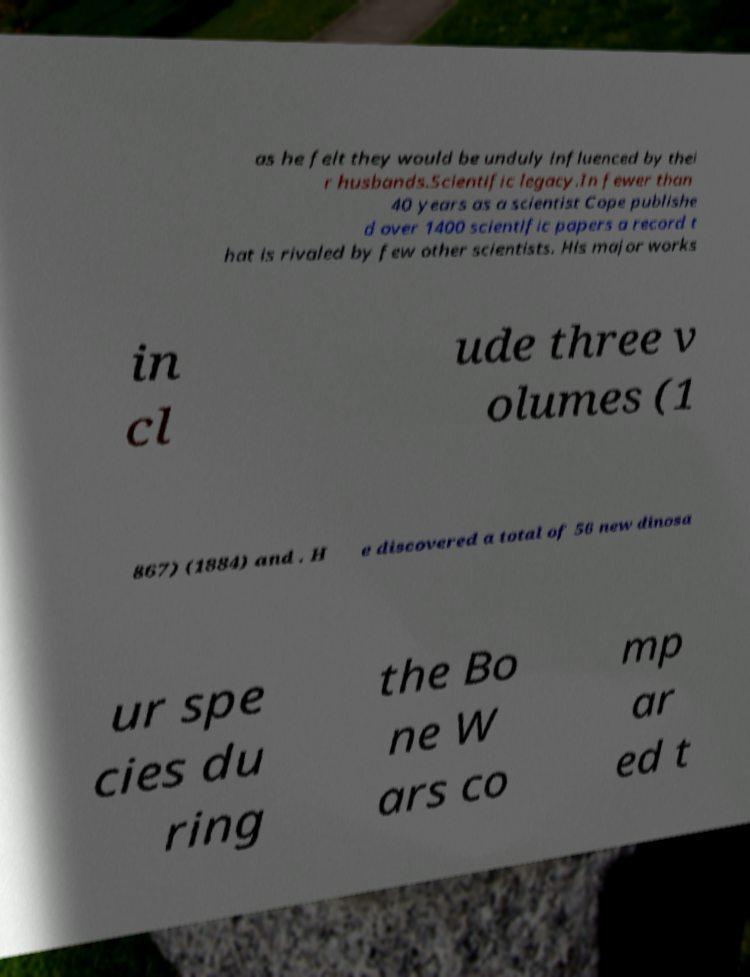Can you read and provide the text displayed in the image?This photo seems to have some interesting text. Can you extract and type it out for me? as he felt they would be unduly influenced by thei r husbands.Scientific legacy.In fewer than 40 years as a scientist Cope publishe d over 1400 scientific papers a record t hat is rivaled by few other scientists. His major works in cl ude three v olumes (1 867) (1884) and . H e discovered a total of 56 new dinosa ur spe cies du ring the Bo ne W ars co mp ar ed t 